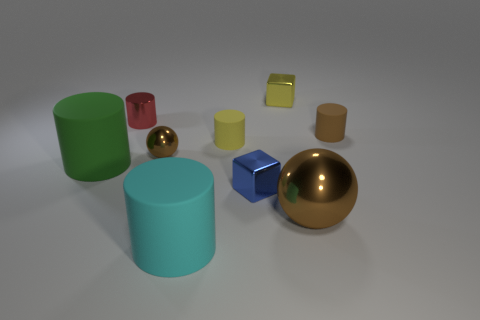How many cylinders are either cyan objects or big red metal things?
Offer a very short reply. 1. There is a blue object; is its size the same as the metal block behind the big green thing?
Give a very brief answer. Yes. Are there more small red cylinders to the right of the small blue shiny object than large purple cylinders?
Your answer should be compact. No. What is the size of the yellow cylinder that is the same material as the big green thing?
Your answer should be very brief. Small. Are there any things of the same color as the big metal ball?
Offer a very short reply. Yes. How many things are small cylinders or brown shiny balls that are left of the large cyan rubber cylinder?
Keep it short and to the point. 4. Is the number of tiny brown objects greater than the number of small metallic cylinders?
Ensure brevity in your answer.  Yes. What is the size of the metallic object that is the same color as the tiny metallic ball?
Your answer should be compact. Large. Are there any other cubes made of the same material as the small blue block?
Your answer should be very brief. Yes. There is a brown object that is right of the cyan cylinder and behind the large shiny sphere; what shape is it?
Your response must be concise. Cylinder. 